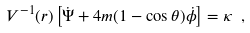Convert formula to latex. <formula><loc_0><loc_0><loc_500><loc_500>V ^ { - 1 } ( r ) \left [ \dot { \Psi } + 4 m ( 1 - \cos \theta ) \dot { \phi } \right ] = \kappa \ ,</formula> 